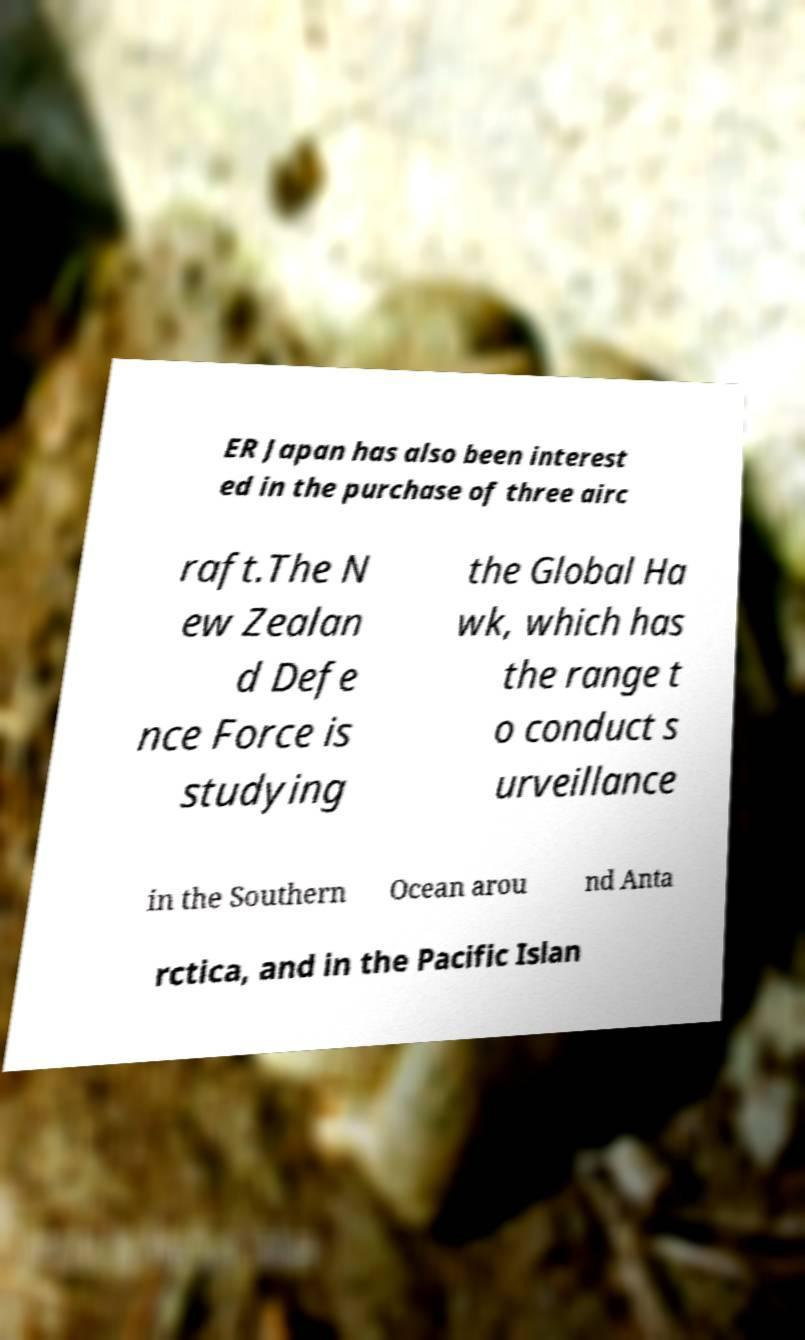Can you accurately transcribe the text from the provided image for me? ER Japan has also been interest ed in the purchase of three airc raft.The N ew Zealan d Defe nce Force is studying the Global Ha wk, which has the range t o conduct s urveillance in the Southern Ocean arou nd Anta rctica, and in the Pacific Islan 